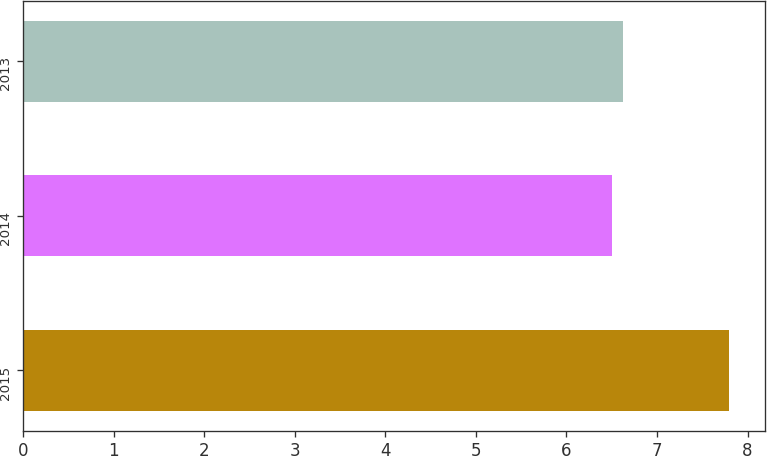Convert chart. <chart><loc_0><loc_0><loc_500><loc_500><bar_chart><fcel>2015<fcel>2014<fcel>2013<nl><fcel>7.8<fcel>6.5<fcel>6.63<nl></chart> 